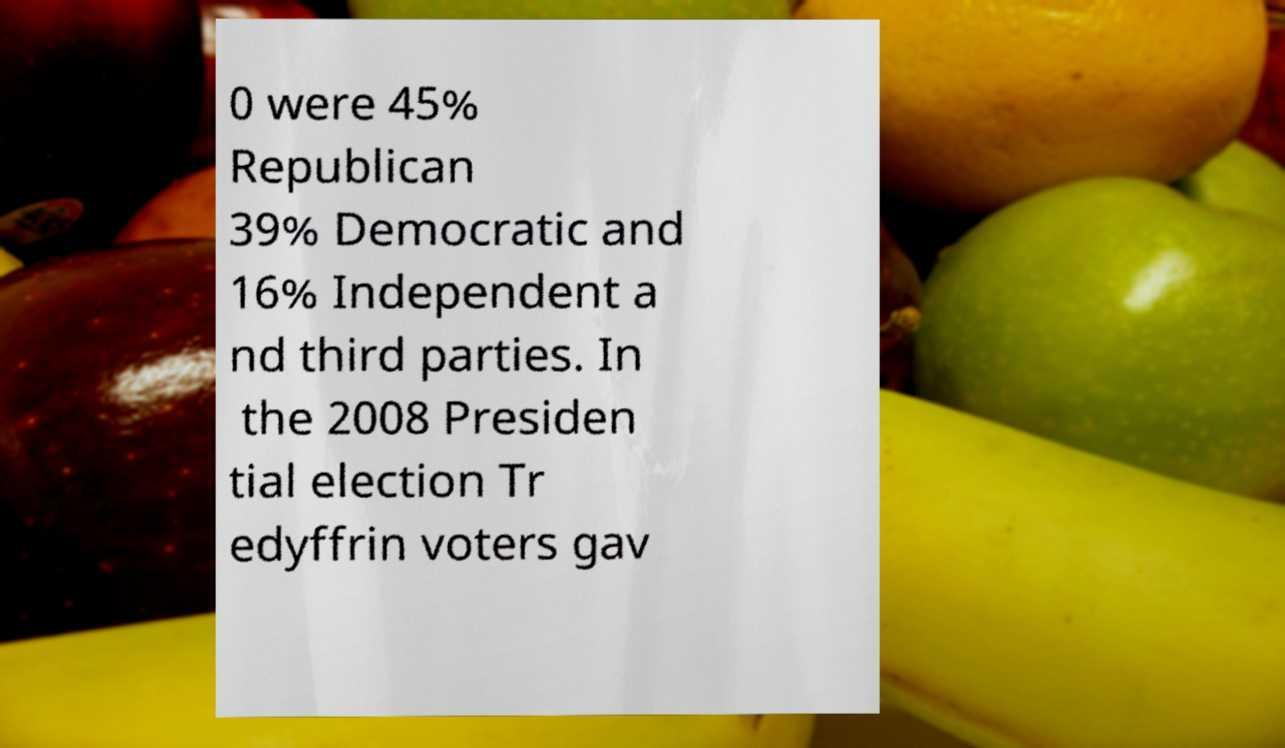For documentation purposes, I need the text within this image transcribed. Could you provide that? 0 were 45% Republican 39% Democratic and 16% Independent a nd third parties. In the 2008 Presiden tial election Tr edyffrin voters gav 